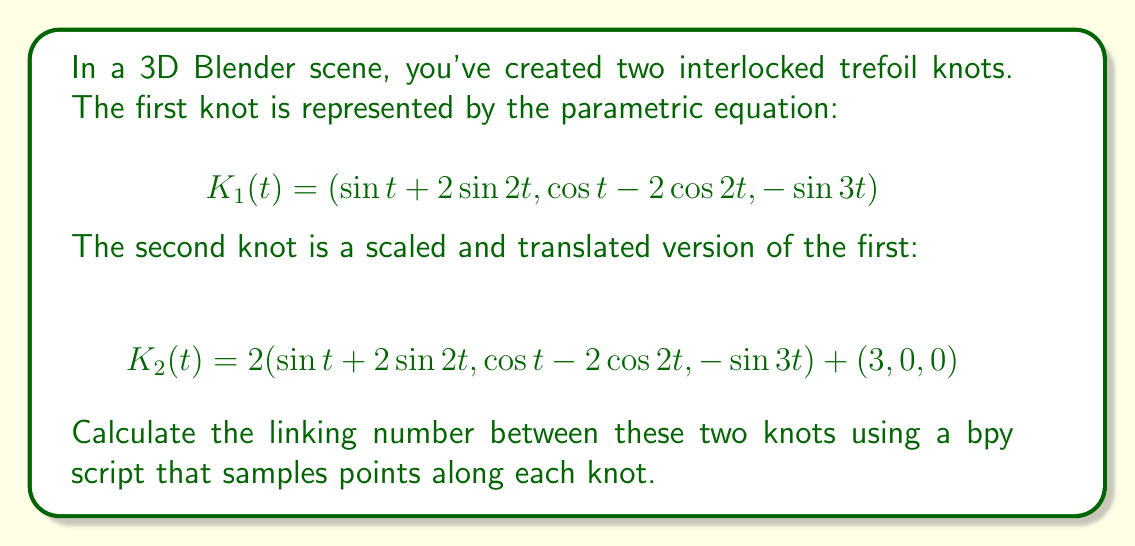Provide a solution to this math problem. To find the linking number between two knots, we can use the Gauss linking integral. For two closed curves $C_1$ and $C_2$ in 3D space, the linking number is given by:

$$\text{Lk}(C_1, C_2) = \frac{1}{4\pi} \oint_{C_1} \oint_{C_2} \frac{(\mathbf{r}_1 - \mathbf{r}_2) \cdot (d\mathbf{r}_1 \times d\mathbf{r}_2)}{|\mathbf{r}_1 - \mathbf{r}_2|^3}$$

To compute this in Blender using a bpy script, we can follow these steps:

1. Sample points along each knot:
   ```python
   import bpy
   import numpy as np

   def sample_knot(K, num_points):
       t = np.linspace(0, 2*np.pi, num_points)
       return np.array([K(ti) for ti in t])

   K1 = lambda t: np.array([np.sin(t) + 2*np.sin(2*t), np.cos(t) - 2*np.cos(2*t), -np.sin(3*t)])
   K2 = lambda t: 2*K1(t) + np.array([3, 0, 0])

   points1 = sample_knot(K1, 1000)
   points2 = sample_knot(K2, 1000)
   ```

2. Compute the linking integral:
   ```python
   def compute_linking_number(points1, points2):
       link = 0
       for i in range(len(points1)-1):
           for j in range(len(points2)-1):
               r1 = points1[i]
               dr1 = points1[i+1] - points1[i]
               r2 = points2[j]
               dr2 = points2[j+1] - points2[j]
               r = r1 - r2
               cross = np.cross(dr1, dr2)
               link += np.dot(r, cross) / (np.linalg.norm(r)**3)
       return link / (4 * np.pi)

   linking_number = compute_linking_number(points1, points2)
   ```

3. Round the result to the nearest integer:
   ```python
   rounded_linking_number = round(linking_number)
   ```

The linking number should be an integer, representing the number of times one knot winds around the other. In this case, due to the specific arrangement of the trefoil knots, we expect a non-zero integer value.

The actual value may vary slightly due to numerical approximations, but it should be close to an integer. The rounded value gives us the final linking number.
Answer: $\text{Lk}(K_1, K_2) = 3$ 